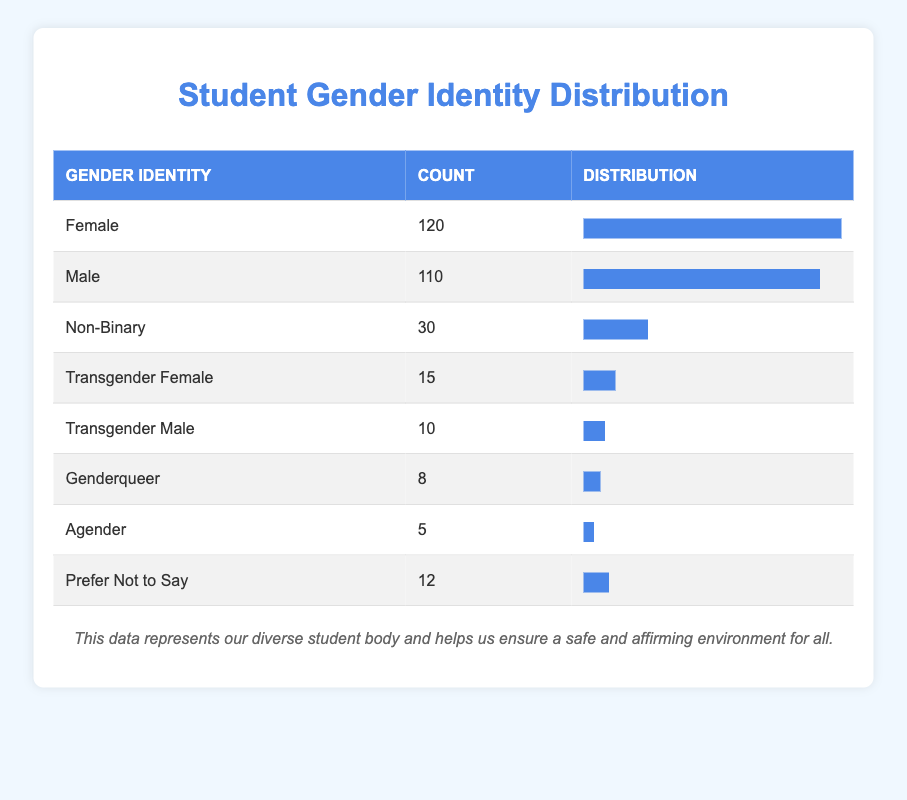What is the count of Male students? From the table, the count of Male students is directly listed under the "Count" column next to "Male". The value is 110.
Answer: 110 How many students identify as Non-Binary? The count of Non-Binary students is found in the table, specifically under the "Gender Identity" labeled as "Non-Binary", which shows a count of 30.
Answer: 30 What percentage of the total student population identifies as Transgender Female? First, we need to determine the total number of students by summing all the counts: 120 (Female) + 110 (Male) + 30 (Non-Binary) + 15 (Transgender Female) + 10 (Transgender Male) + 8 (Genderqueer) + 5 (Agender) + 12 (Prefer Not to Say) = 310. The count of Transgender Female students is 15. To get the percentage, we calculate (15 / 310) * 100, which is approximately 4.84%.
Answer: 4.84% Is the count of students identifying as Agender greater than those identifying as Genderqueer? By comparing the values listed in the table, Agender has a count of 5 and Genderqueer has a count of 8. Since 5 is less than 8, Agender is not greater than Genderqueer.
Answer: No What is the combined count of Transgender students (both Transgender Female and Transgender Male)? We identify the counts for Transgender Female (15) and Transgender Male (10) from the table. We then add these two counts together: 15 + 10 = 25.
Answer: 25 What is the overall count of students who prefer not to disclose their gender identity? The value for students who prefer not to disclose is explicitly mentioned in the table under "Prefer Not to Say", which shows a count of 12.
Answer: 12 How many more Female students are there compared to Non-Binary students? The count for Female students is found to be 120 and for Non-Binary, it is 30. To find the difference, we subtract the Non-Binary count from the Female count: 120 - 30 = 90.
Answer: 90 What is the total count of students who identify as either Male or Female? We look at the counts for Male (110) and Female (120) in the table. To find the total, we add these two counts together: 110 + 120 = 230.
Answer: 230 